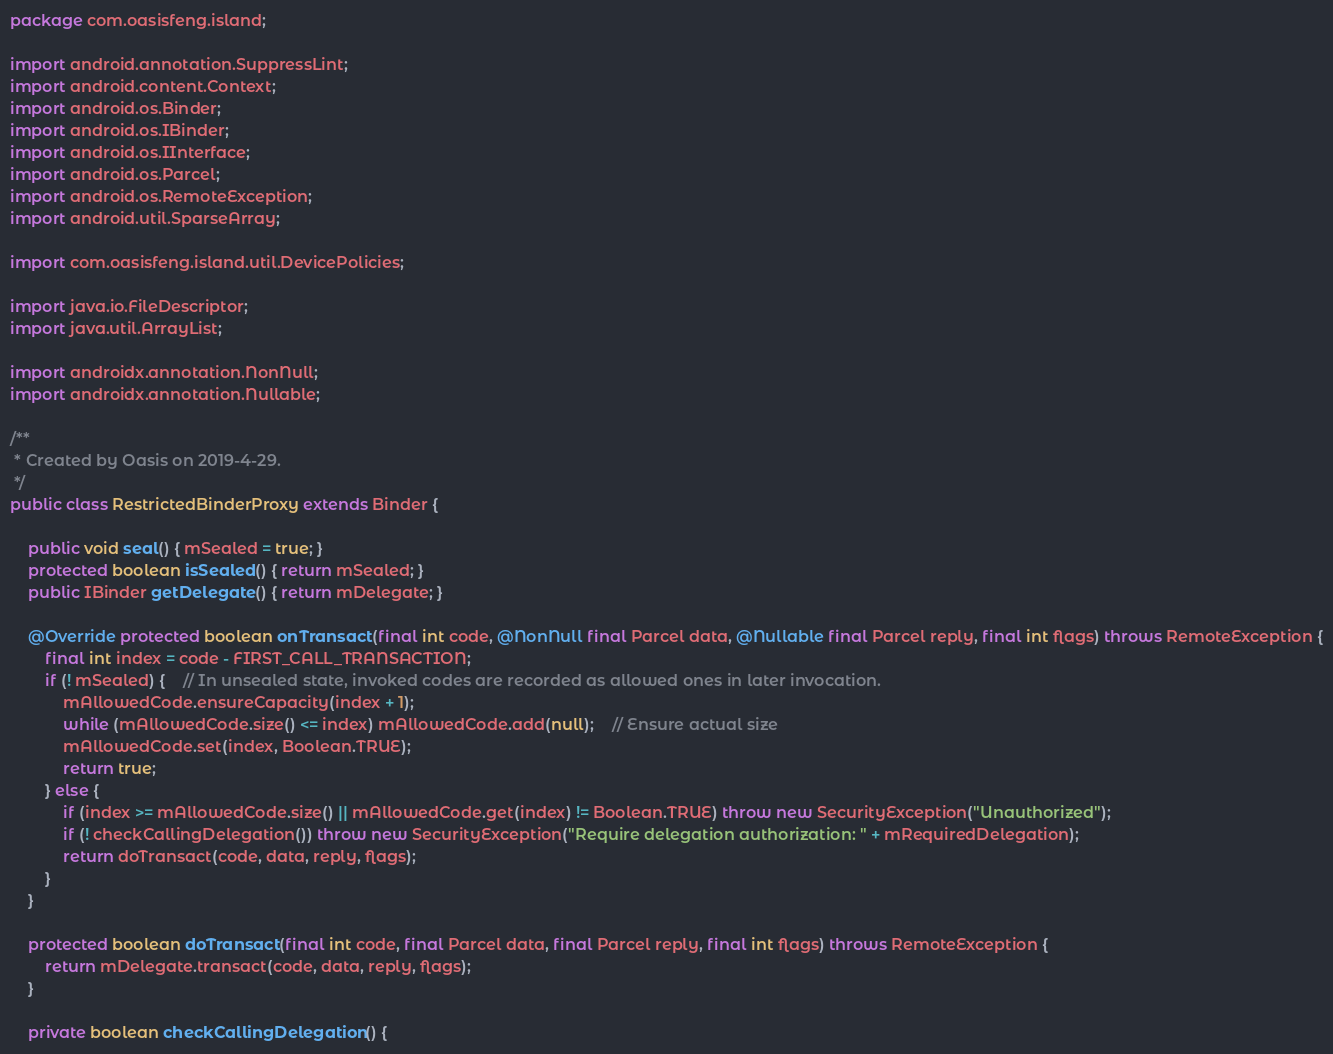<code> <loc_0><loc_0><loc_500><loc_500><_Java_>package com.oasisfeng.island;

import android.annotation.SuppressLint;
import android.content.Context;
import android.os.Binder;
import android.os.IBinder;
import android.os.IInterface;
import android.os.Parcel;
import android.os.RemoteException;
import android.util.SparseArray;

import com.oasisfeng.island.util.DevicePolicies;

import java.io.FileDescriptor;
import java.util.ArrayList;

import androidx.annotation.NonNull;
import androidx.annotation.Nullable;

/**
 * Created by Oasis on 2019-4-29.
 */
public class RestrictedBinderProxy extends Binder {

	public void seal() { mSealed = true; }
	protected boolean isSealed() { return mSealed; }
	public IBinder getDelegate() { return mDelegate; }

	@Override protected boolean onTransact(final int code, @NonNull final Parcel data, @Nullable final Parcel reply, final int flags) throws RemoteException {
		final int index = code - FIRST_CALL_TRANSACTION;
		if (! mSealed) {	// In unsealed state, invoked codes are recorded as allowed ones in later invocation.
			mAllowedCode.ensureCapacity(index + 1);
			while (mAllowedCode.size() <= index) mAllowedCode.add(null);	// Ensure actual size
			mAllowedCode.set(index, Boolean.TRUE);
			return true;
		} else {
			if (index >= mAllowedCode.size() || mAllowedCode.get(index) != Boolean.TRUE) throw new SecurityException("Unauthorized");
			if (! checkCallingDelegation()) throw new SecurityException("Require delegation authorization: " + mRequiredDelegation);
			return doTransact(code, data, reply, flags);
		}
	}

	protected boolean doTransact(final int code, final Parcel data, final Parcel reply, final int flags) throws RemoteException {
		return mDelegate.transact(code, data, reply, flags);
	}

	private boolean checkCallingDelegation() {</code> 